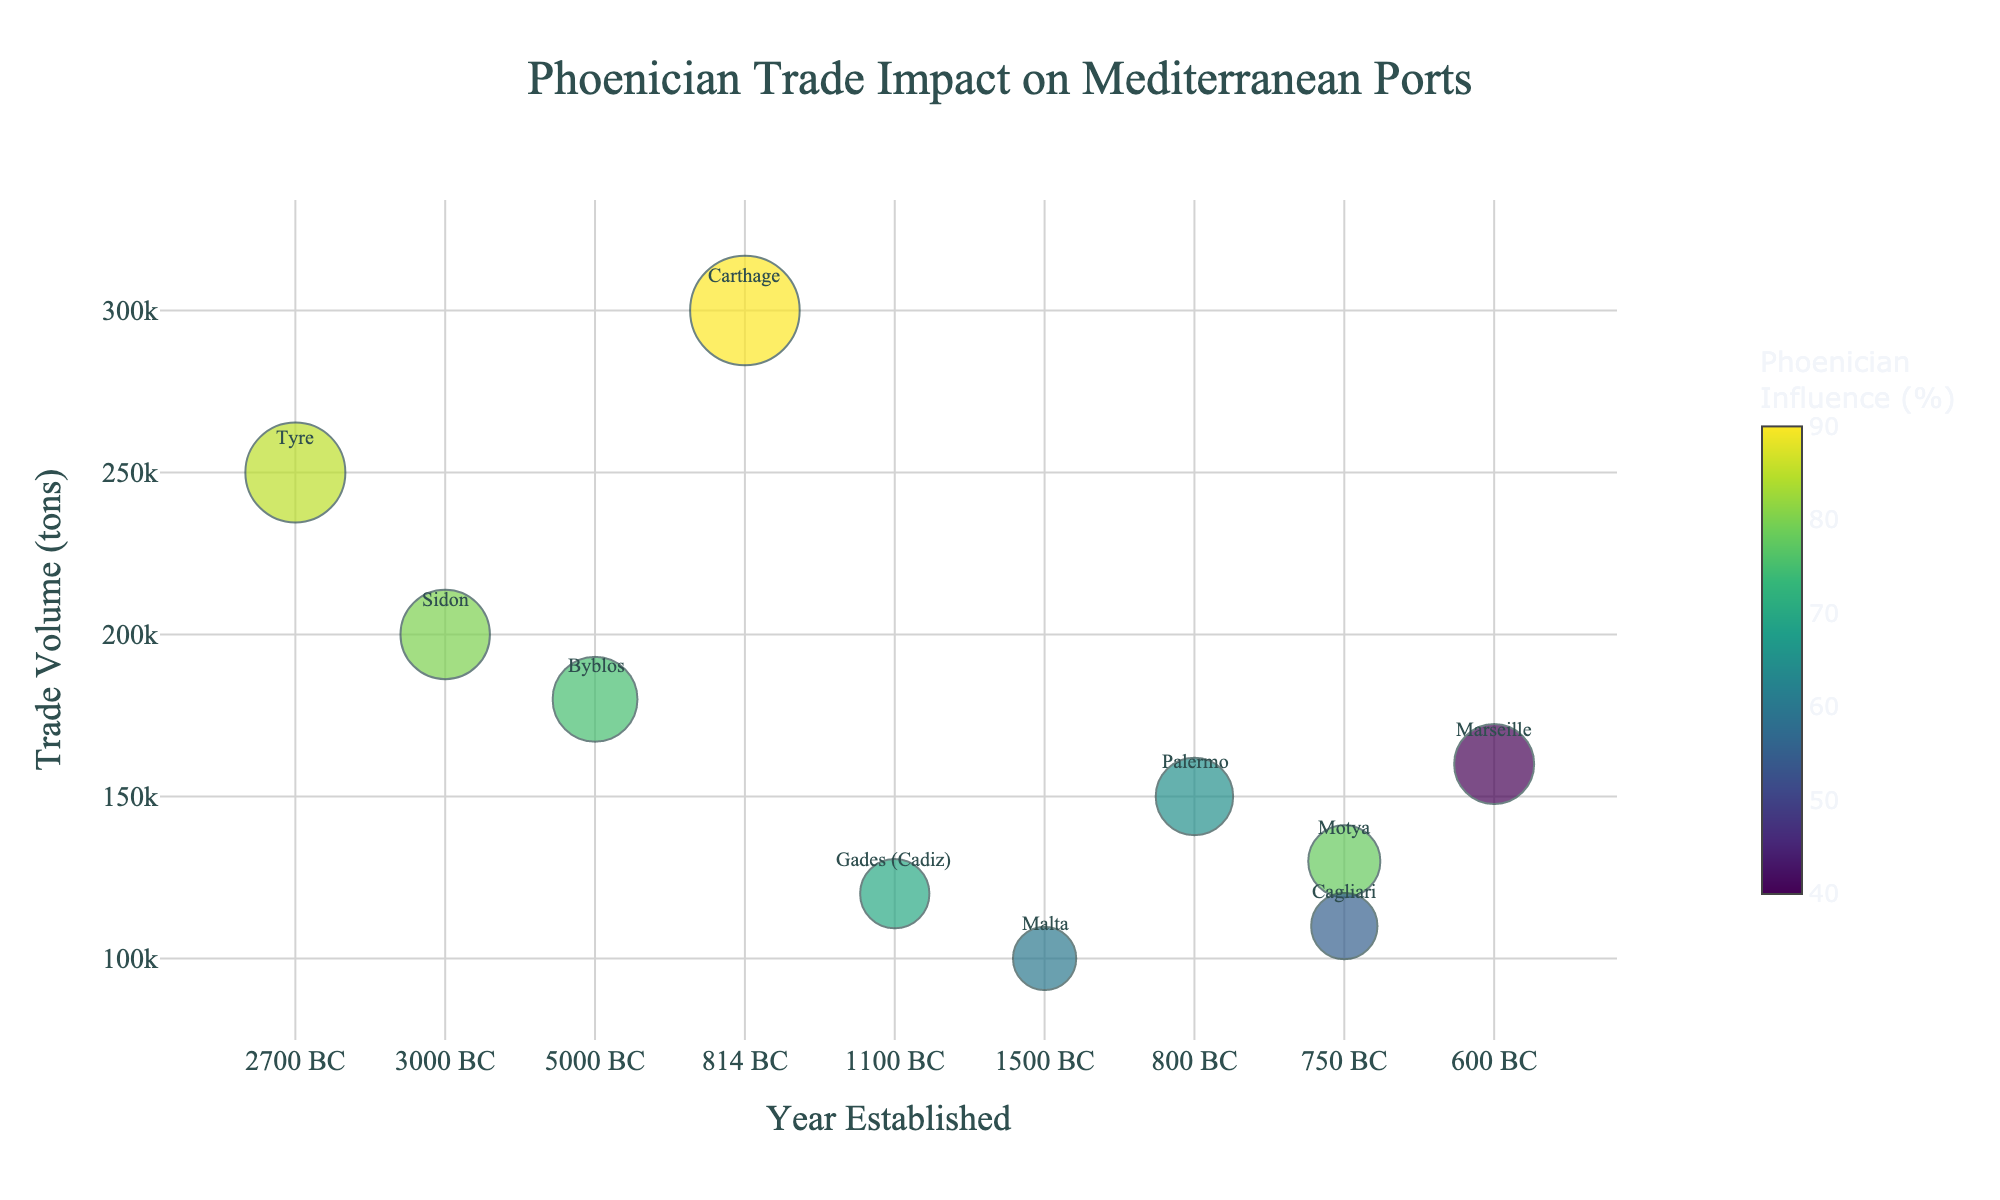Which port has the highest trade volume? By looking at the size of the bubbles (proportional to trade volume) and confirming the hover text, Carthage has the largest bubble indicating the highest trade volume.
Answer: Carthage What is the average Phoenician influence percentage across all ports? To find the average Phoenician influence, sum up the percentages and divide by the number of ports. (85 + 80 + 75 + 90 + 70 + 60 + 65 + 78 + 40 + 55) / 10 = 69.8
Answer: 69.8% Which port was established earliest and what's its trade volume? Check the x-axis for the earliest year and cross-reference that with the corresponding y-axis trade volume. Byblos was established in 5000 BC with a trade volume of 180,000 tons.
Answer: Byblos, 180,000 tons Which port has the lowest Phoenician influence, and what is its trade volume? Look for the bubble with the smallest color intensity on the color scale, then confirm with the hover text. Marseille has the lowest Phoenician influence at 40% and a trade volume of 160,000 tons.
Answer: Marseille, 160,000 tons Which two ports have similar trade volumes but differing Phoenician influence? Compare bubble sizes for similarity and check their color intensity. Tyre and Sidon both have close trade volumes but differing Phoenician influences of 85% and 80%, respectively.
Answer: Tyre and Sidon What's the total trade volume of ports established after 1000 BC? Sum the trade volumes of ports established after this year: Carthage (300,000) + Palermo (150,000) + Motya (130,000) + Marseille (160,000) + Cagliari (110,000) = 850,000 tons.
Answer: 850,000 tons Which port marked with the highest Phoenician influence and what year was it established? Identify the highest color intensity on the color scale and check the hover text: Carthage with a 90% influence was established in 814 BC.
Answer: Carthage, 814 BC How many ports have a trade volume of over 150,000 tons? Count the bubbles larger than the equivalent size on the y-axis, confirmed by hover text. These ports are: Tyre, Sidon, Byblos, Carthage, Palermo, and Marseille. There are 6 in total.
Answer: 6 What can be deduced about the relationship between the year a port was established and its Phoenician influence? Observe the distribution of colors across the x-axis. There is no clear correlation suggesting that the year of establishment directly influences the Phoenician influence percentage.
Answer: No clear correlation Comparing Malta and Gades (Cadiz), which has a higher trade volume and Phoenician influence? Check the size and color of the bubbles while referring to the hover text: Gades (Cadiz) has a higher trade volume (120,000 tons) and higher Phoenician influence (70%) compared to Malta’s 100,000 tons and 60%.
Answer: Gades (Cadiz) 